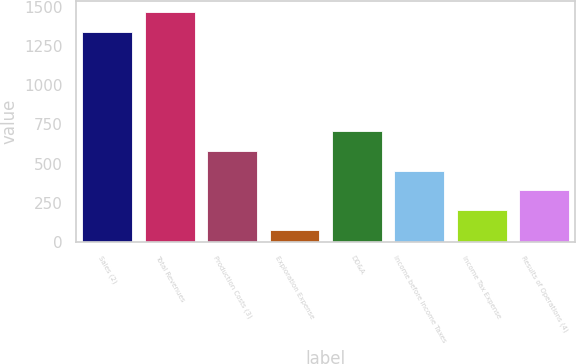Convert chart. <chart><loc_0><loc_0><loc_500><loc_500><bar_chart><fcel>Sales (2)<fcel>Total Revenues<fcel>Production Costs (3)<fcel>Exploration Expense<fcel>DD&A<fcel>Income before Income Taxes<fcel>Income Tax Expense<fcel>Results of Operations (4)<nl><fcel>1341<fcel>1467.6<fcel>581.4<fcel>75<fcel>708<fcel>454.8<fcel>201.6<fcel>328.2<nl></chart> 